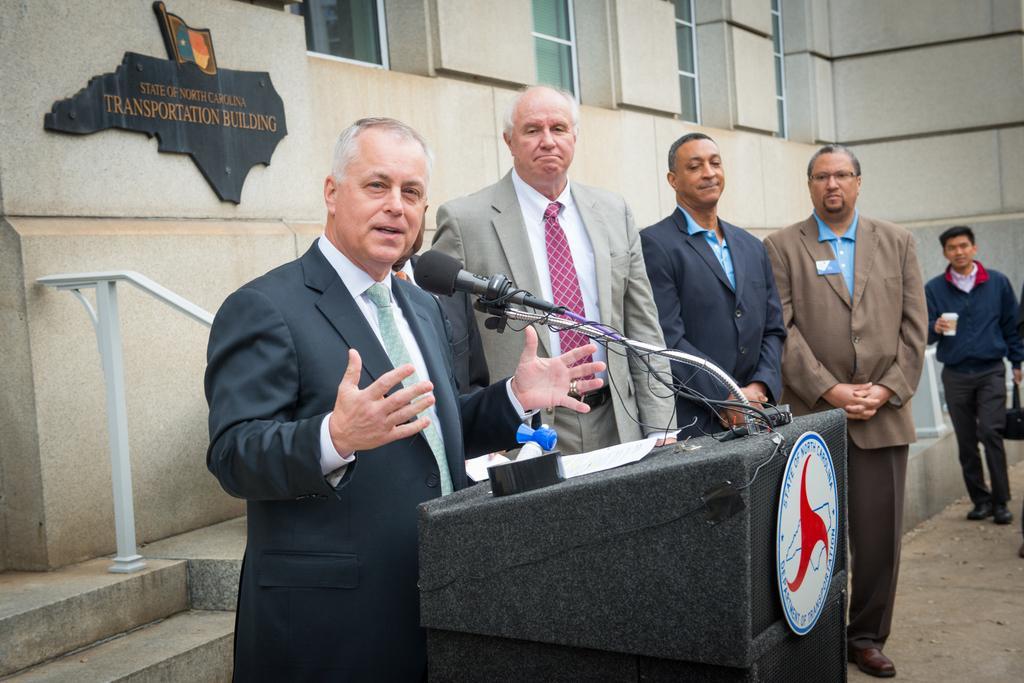Can you describe this image briefly? In this picture I can see few people are standing among them one person is standing and talking in front of the mike, side we can see one person holding a bottle and walking, behind we can see a board to the building. 